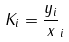Convert formula to latex. <formula><loc_0><loc_0><loc_500><loc_500>K _ { i } = \frac { y _ { i } } { x } _ { i }</formula> 